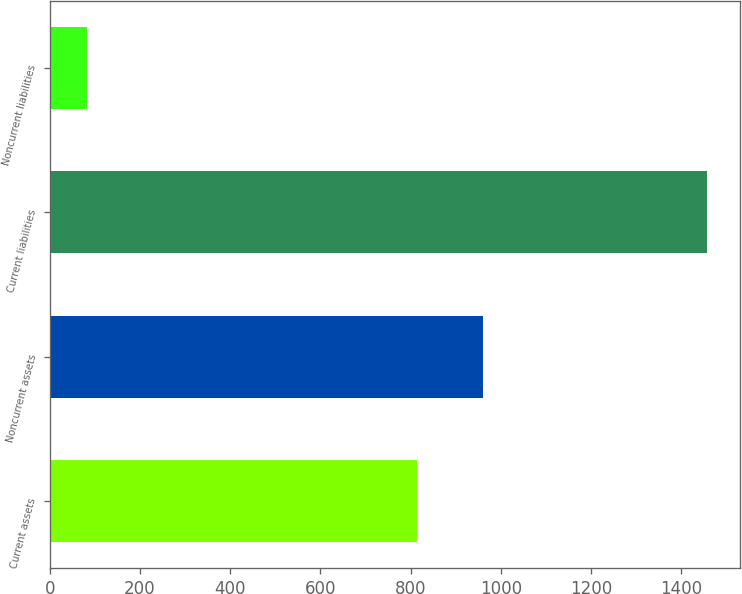Convert chart. <chart><loc_0><loc_0><loc_500><loc_500><bar_chart><fcel>Current assets<fcel>Noncurrent assets<fcel>Current liabilities<fcel>Noncurrent liabilities<nl><fcel>814.1<fcel>959.9<fcel>1457.3<fcel>81.7<nl></chart> 